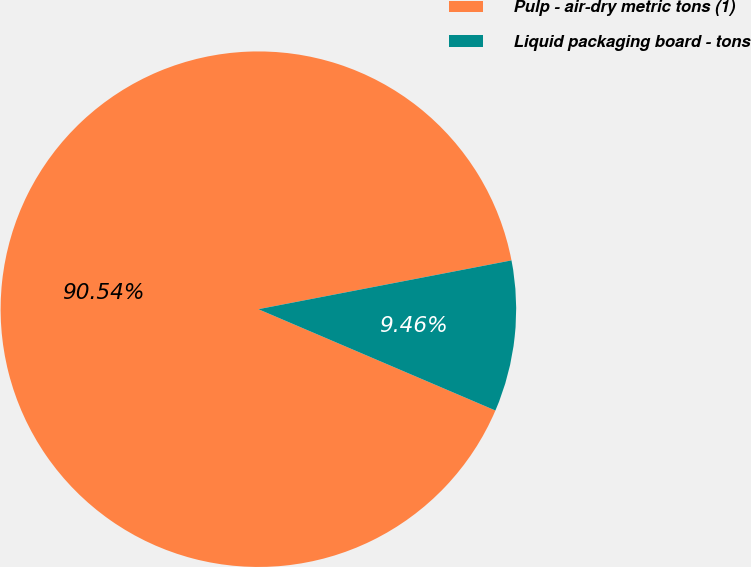<chart> <loc_0><loc_0><loc_500><loc_500><pie_chart><fcel>Pulp - air-dry metric tons (1)<fcel>Liquid packaging board - tons<nl><fcel>90.54%<fcel>9.46%<nl></chart> 